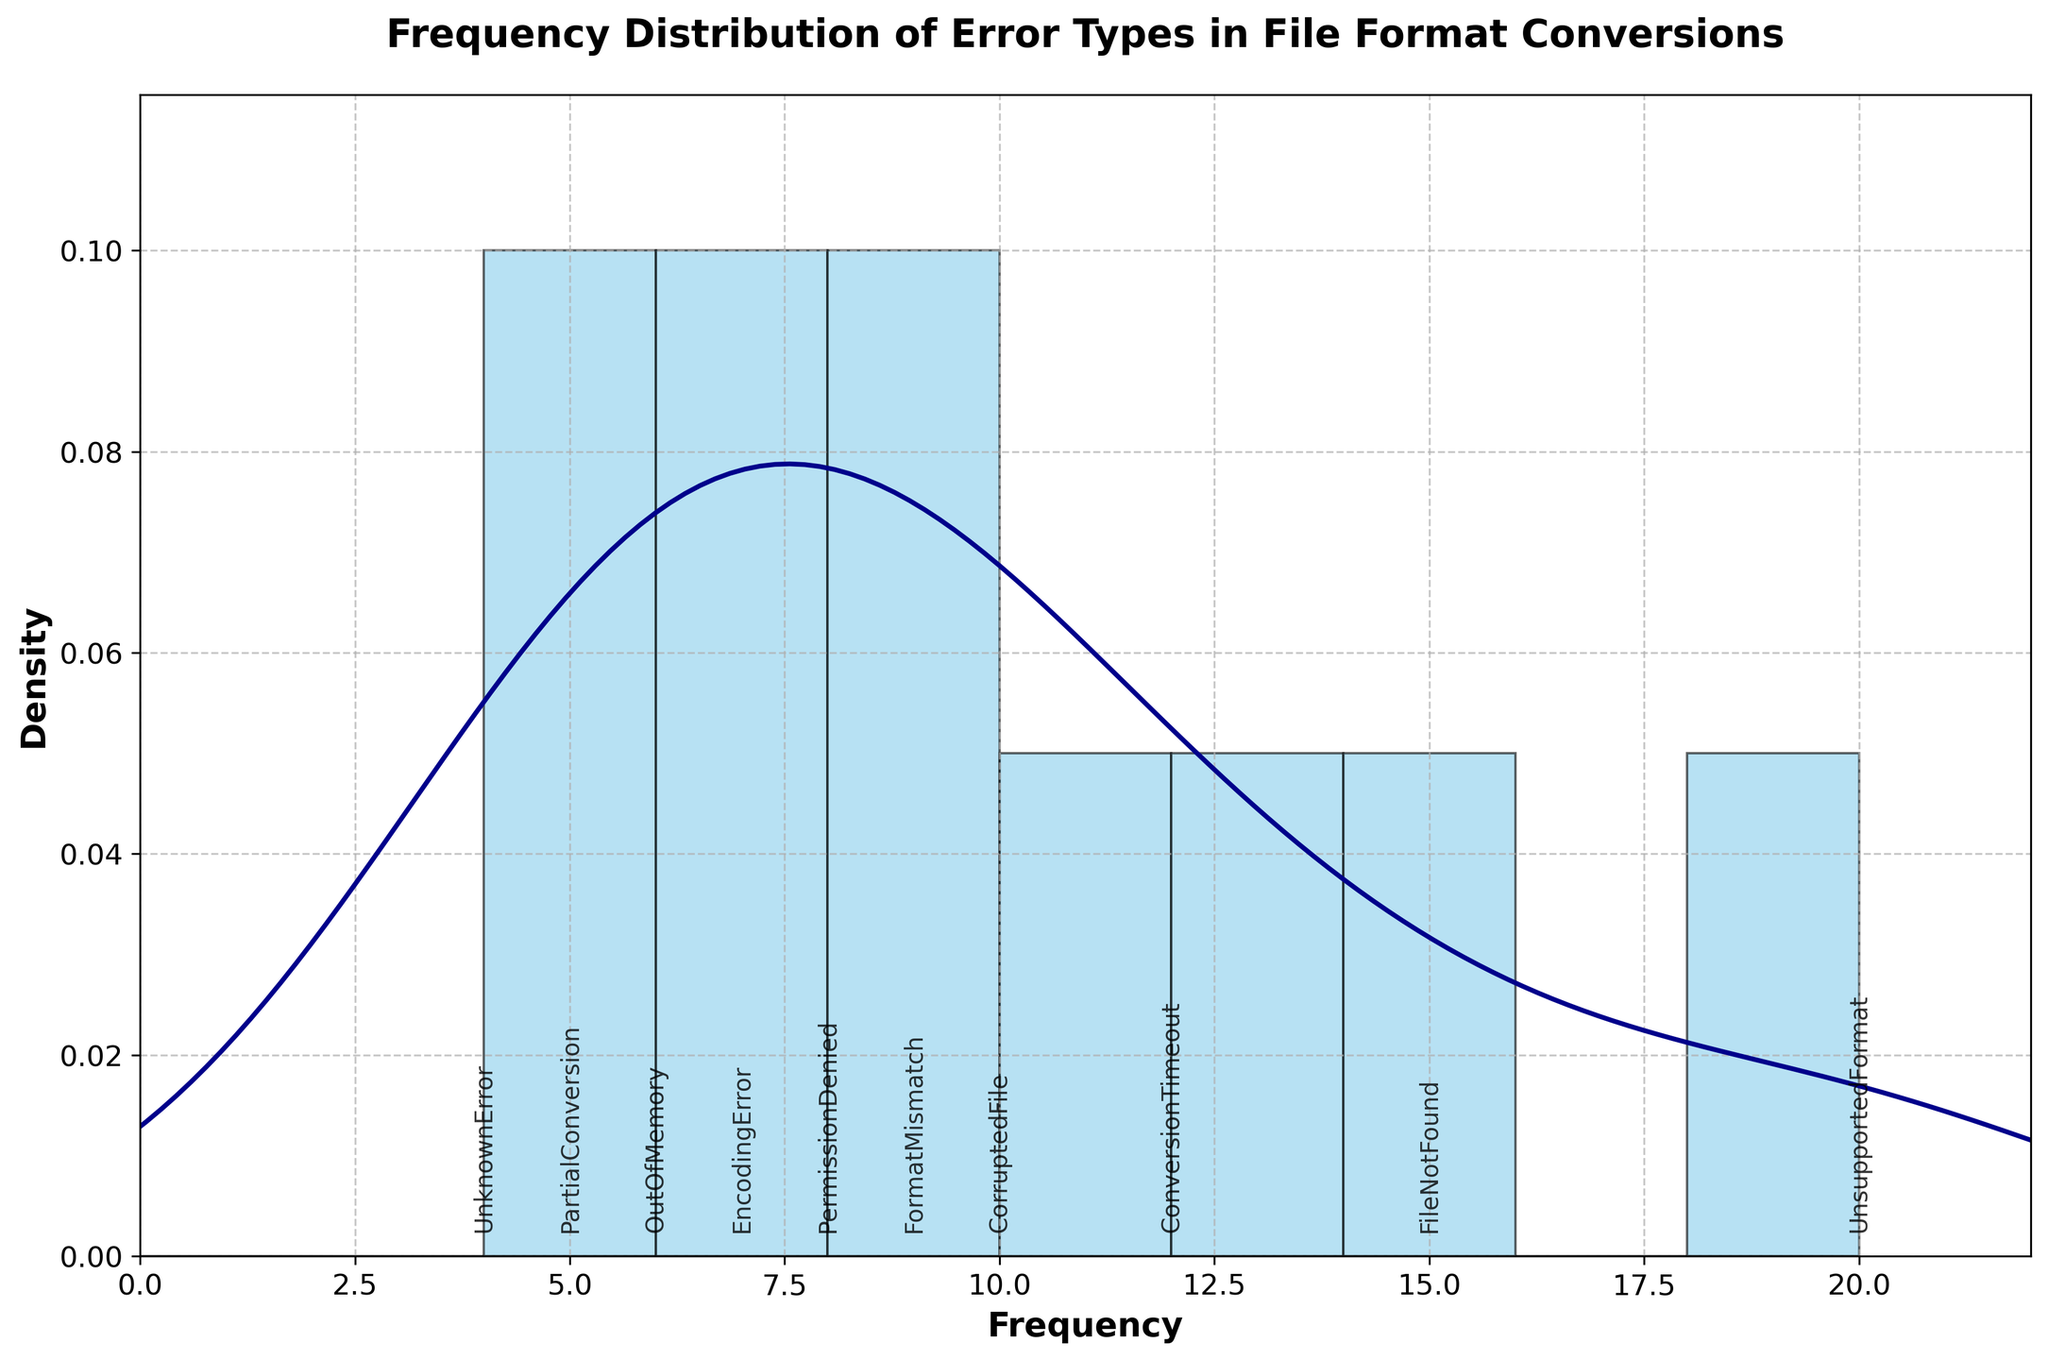what's the title of the figure? The title of the figure is typically found at the top of the chart. In this case, the title is explicitly set and should be clear.
Answer: Frequency Distribution of Error Types in File Format Conversions how many error types are displayed in the figure? Each error type corresponds to a different data point on the x-axis annotation. Count these points to determine the total number of error types.
Answer: 10 which error type has the highest frequency? By examining the x-axis annotations and their corresponding positions on the frequency scale, identify the error type with the highest value.
Answer: UnsupportedFormat how does the frequency of "FileNotFound" compare to "UnknownError"? Locate the position of "FileNotFound" and "UnknownError" on the frequency scale, then compare their values.
Answer: FileNotFound's frequency (15) is higher than UnknownError's frequency (4) what range of frequency values does the x-axis cover? Examine the x-axis range, which spans from the minimum to the maximum frequency values shown in the figure.
Answer: 0 to 22 what is the average frequency of all error types? Add up the frequencies of all error types and divide by the number of error types to get the average.
Answer: (15 + 8 + 20 + 12 + 10 + 6 + 5 + 7 + 9 + 4) / 10 = 9.6 which error types have frequencies greater than the median frequency? Calculate the median frequency and identify the error types whose frequencies are above this value.
Answer: UnsupportedFormat, FileNotFound, ConversionTimeout, FormatMismatch, CorruptedFile is the distribution of error frequencies positively or negatively skewed? The skewness of the distribution can be inferred from the shape of the KDE line—it is positively skewed if it has a long right tail, and negatively skewed if it has a long left tail.
Answer: Positively skewed 